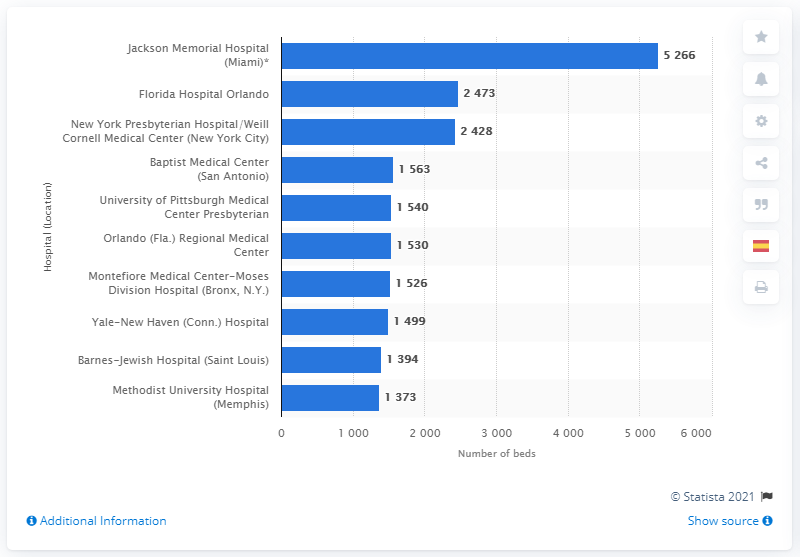Indicate a few pertinent items in this graphic. According to the ranking, Florida Hospital Orlando was ranked as the second best non-profit hospital in the United States. 